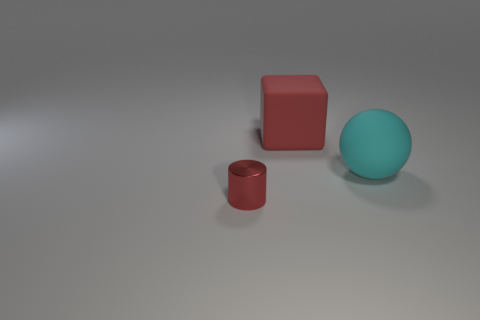Add 1 metal things. How many objects exist? 4 Subtract all blocks. How many objects are left? 2 Subtract 0 yellow cylinders. How many objects are left? 3 Subtract all gray cylinders. Subtract all cyan things. How many objects are left? 2 Add 2 big matte cubes. How many big matte cubes are left? 3 Add 2 large green matte cylinders. How many large green matte cylinders exist? 2 